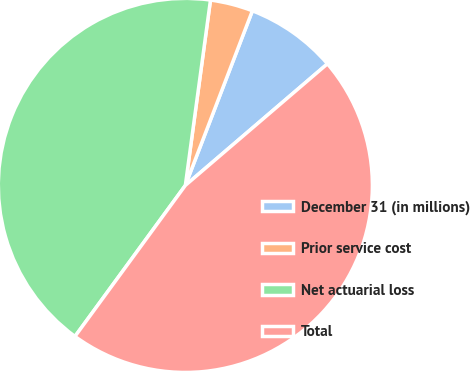<chart> <loc_0><loc_0><loc_500><loc_500><pie_chart><fcel>December 31 (in millions)<fcel>Prior service cost<fcel>Net actuarial loss<fcel>Total<nl><fcel>7.9%<fcel>3.69%<fcel>42.1%<fcel>46.31%<nl></chart> 